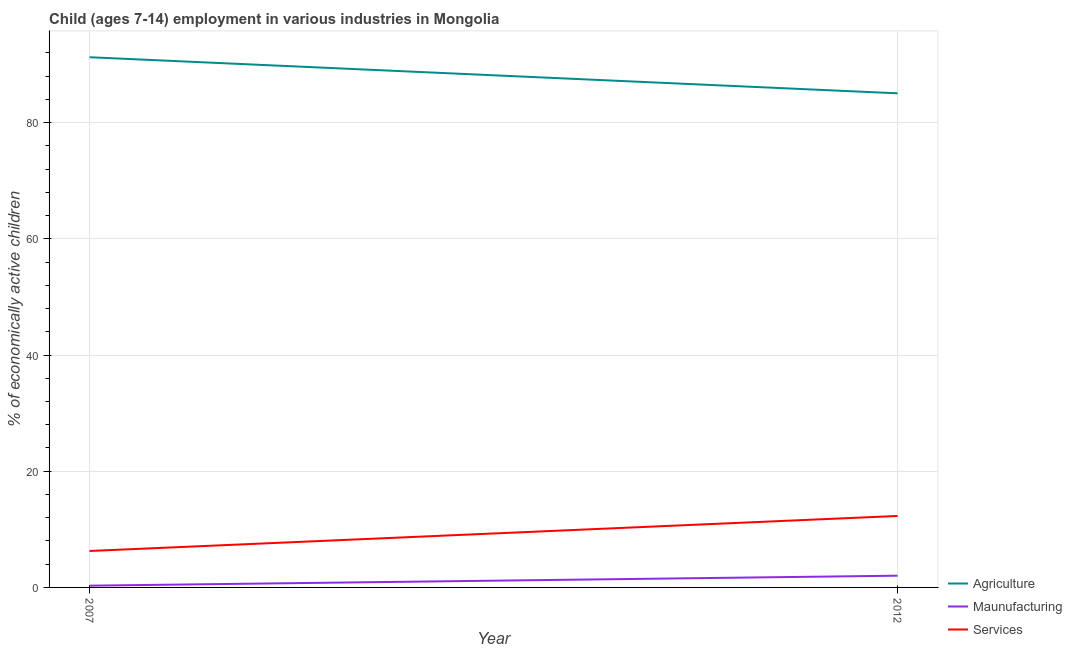How many different coloured lines are there?
Provide a short and direct response. 3. Does the line corresponding to percentage of economically active children in manufacturing intersect with the line corresponding to percentage of economically active children in services?
Offer a very short reply. No. Is the number of lines equal to the number of legend labels?
Provide a succinct answer. Yes. What is the percentage of economically active children in manufacturing in 2007?
Provide a succinct answer. 0.3. Across all years, what is the maximum percentage of economically active children in agriculture?
Offer a terse response. 91.25. Across all years, what is the minimum percentage of economically active children in manufacturing?
Your answer should be compact. 0.3. In which year was the percentage of economically active children in manufacturing maximum?
Your response must be concise. 2012. What is the total percentage of economically active children in manufacturing in the graph?
Provide a succinct answer. 2.32. What is the difference between the percentage of economically active children in services in 2007 and that in 2012?
Ensure brevity in your answer.  -6.03. What is the difference between the percentage of economically active children in agriculture in 2012 and the percentage of economically active children in manufacturing in 2007?
Ensure brevity in your answer.  84.74. What is the average percentage of economically active children in services per year?
Your answer should be very brief. 9.29. In the year 2007, what is the difference between the percentage of economically active children in services and percentage of economically active children in agriculture?
Offer a very short reply. -84.98. In how many years, is the percentage of economically active children in manufacturing greater than 88 %?
Your response must be concise. 0. What is the ratio of the percentage of economically active children in agriculture in 2007 to that in 2012?
Your answer should be very brief. 1.07. Is the percentage of economically active children in manufacturing in 2007 less than that in 2012?
Ensure brevity in your answer.  Yes. In how many years, is the percentage of economically active children in agriculture greater than the average percentage of economically active children in agriculture taken over all years?
Offer a very short reply. 1. Is it the case that in every year, the sum of the percentage of economically active children in agriculture and percentage of economically active children in manufacturing is greater than the percentage of economically active children in services?
Your response must be concise. Yes. Does the percentage of economically active children in manufacturing monotonically increase over the years?
Your answer should be very brief. Yes. Is the percentage of economically active children in services strictly less than the percentage of economically active children in agriculture over the years?
Provide a succinct answer. Yes. Does the graph contain grids?
Keep it short and to the point. Yes. How many legend labels are there?
Offer a very short reply. 3. How are the legend labels stacked?
Provide a succinct answer. Vertical. What is the title of the graph?
Keep it short and to the point. Child (ages 7-14) employment in various industries in Mongolia. What is the label or title of the Y-axis?
Your response must be concise. % of economically active children. What is the % of economically active children in Agriculture in 2007?
Keep it short and to the point. 91.25. What is the % of economically active children in Maunufacturing in 2007?
Ensure brevity in your answer.  0.3. What is the % of economically active children in Services in 2007?
Offer a terse response. 6.27. What is the % of economically active children in Agriculture in 2012?
Make the answer very short. 85.04. What is the % of economically active children of Maunufacturing in 2012?
Your response must be concise. 2.02. Across all years, what is the maximum % of economically active children in Agriculture?
Provide a succinct answer. 91.25. Across all years, what is the maximum % of economically active children in Maunufacturing?
Ensure brevity in your answer.  2.02. Across all years, what is the minimum % of economically active children of Agriculture?
Keep it short and to the point. 85.04. Across all years, what is the minimum % of economically active children in Services?
Your answer should be very brief. 6.27. What is the total % of economically active children of Agriculture in the graph?
Ensure brevity in your answer.  176.29. What is the total % of economically active children in Maunufacturing in the graph?
Give a very brief answer. 2.32. What is the total % of economically active children in Services in the graph?
Keep it short and to the point. 18.57. What is the difference between the % of economically active children in Agriculture in 2007 and that in 2012?
Provide a succinct answer. 6.21. What is the difference between the % of economically active children of Maunufacturing in 2007 and that in 2012?
Provide a short and direct response. -1.72. What is the difference between the % of economically active children of Services in 2007 and that in 2012?
Ensure brevity in your answer.  -6.03. What is the difference between the % of economically active children in Agriculture in 2007 and the % of economically active children in Maunufacturing in 2012?
Make the answer very short. 89.23. What is the difference between the % of economically active children of Agriculture in 2007 and the % of economically active children of Services in 2012?
Keep it short and to the point. 78.95. What is the difference between the % of economically active children of Maunufacturing in 2007 and the % of economically active children of Services in 2012?
Keep it short and to the point. -12. What is the average % of economically active children of Agriculture per year?
Your response must be concise. 88.14. What is the average % of economically active children in Maunufacturing per year?
Ensure brevity in your answer.  1.16. What is the average % of economically active children in Services per year?
Give a very brief answer. 9.29. In the year 2007, what is the difference between the % of economically active children of Agriculture and % of economically active children of Maunufacturing?
Give a very brief answer. 90.95. In the year 2007, what is the difference between the % of economically active children in Agriculture and % of economically active children in Services?
Keep it short and to the point. 84.98. In the year 2007, what is the difference between the % of economically active children in Maunufacturing and % of economically active children in Services?
Offer a very short reply. -5.97. In the year 2012, what is the difference between the % of economically active children of Agriculture and % of economically active children of Maunufacturing?
Offer a terse response. 83.02. In the year 2012, what is the difference between the % of economically active children of Agriculture and % of economically active children of Services?
Your answer should be very brief. 72.74. In the year 2012, what is the difference between the % of economically active children of Maunufacturing and % of economically active children of Services?
Your answer should be compact. -10.28. What is the ratio of the % of economically active children in Agriculture in 2007 to that in 2012?
Your answer should be compact. 1.07. What is the ratio of the % of economically active children in Maunufacturing in 2007 to that in 2012?
Ensure brevity in your answer.  0.15. What is the ratio of the % of economically active children in Services in 2007 to that in 2012?
Make the answer very short. 0.51. What is the difference between the highest and the second highest % of economically active children in Agriculture?
Your response must be concise. 6.21. What is the difference between the highest and the second highest % of economically active children of Maunufacturing?
Provide a short and direct response. 1.72. What is the difference between the highest and the second highest % of economically active children of Services?
Your response must be concise. 6.03. What is the difference between the highest and the lowest % of economically active children of Agriculture?
Your answer should be very brief. 6.21. What is the difference between the highest and the lowest % of economically active children of Maunufacturing?
Your answer should be very brief. 1.72. What is the difference between the highest and the lowest % of economically active children of Services?
Ensure brevity in your answer.  6.03. 